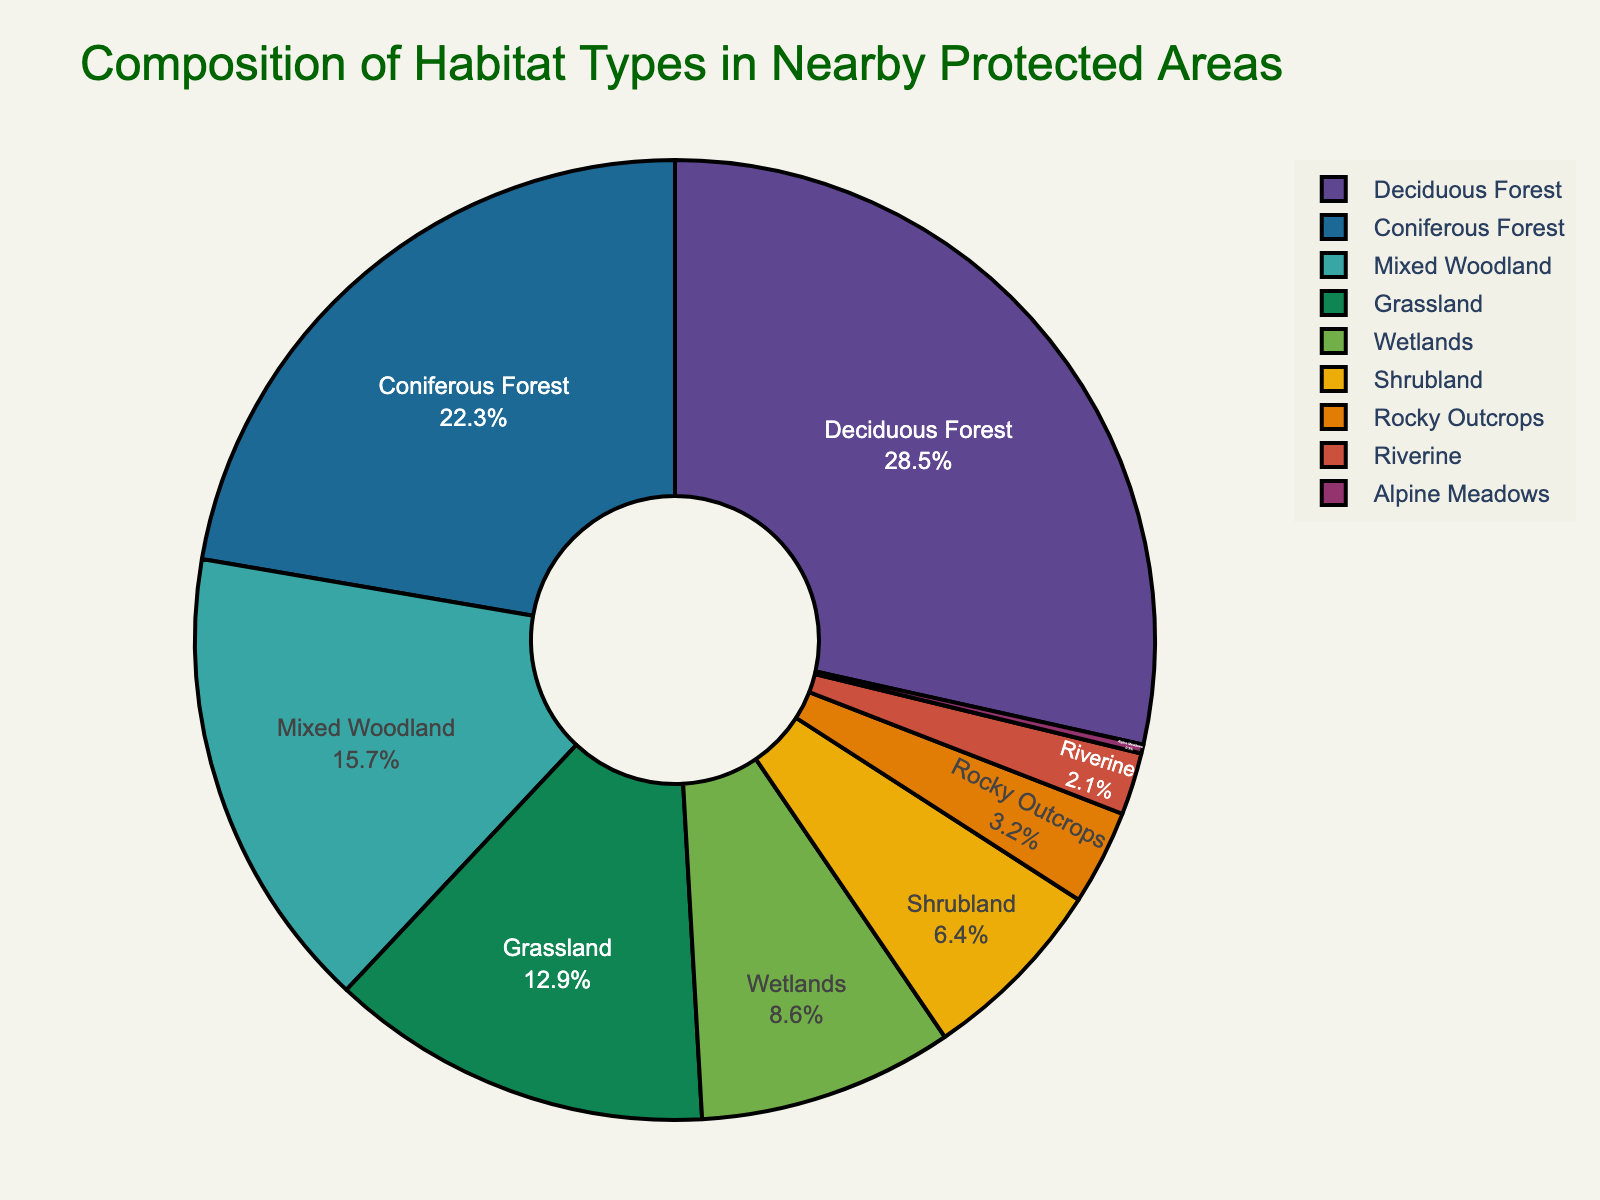What are the top three habitat types by percentage? To find the top three habitat types by percentage, we refer to the slice sizes in the pie chart. The top three are: Deciduous Forest (28.5%), Coniferous Forest (22.3%), and Mixed Woodland (15.7%).
Answer: Deciduous Forest, Coniferous Forest, Mixed Woodland Which habitat type occupies the smallest percentage in the protected areas? Look for the smallest slice in the pie chart. The Alpine Meadows slice is the smallest, occupying 0.3% of the area.
Answer: Alpine Meadows What is the combined percentage of wetlands, shrubland, and rocky outcrops? Add the percentages of Wetlands (8.6%), Shrubland (6.4%), and Rocky Outcrops (3.2%). 8.6 + 6.4 + 3.2 = 18.2%.
Answer: 18.2% How does the percentage of coniferous forest compare to grassland? Refer to the chart slices. Coniferous Forest is 22.3%, and Grassland is 12.9%. Coniferous Forest is more than Grassland by 22.3 - 12.9 = 9.4%.
Answer: Coniferous Forest is 9.4% more than Grassland Which two habitat types combined have a percentage closest to 30%? Examine the chart and add various pairs to find the closest sum to 30%. Deciduous Forest (28.5%) and Alpine Meadows (0.3%) sum to 28.8%, which is the closest to 30%.
Answer: Deciduous Forest and Alpine Meadows What is the difference in percentage between the habitat type with the second largest area and the habitat type with the fifth largest area? The second largest is Coniferous Forest (22.3%), and the fifth largest is Wetlands (8.6%). The difference is 22.3 - 8.6 = 13.7%.
Answer: 13.7% Which habitats together make up more than 50% of the protected areas? Add the largest percentages until the sum exceeds 50%. Deciduous Forest (28.5%) + Coniferous Forest (22.3%) = 50.8%, which just exceeds 50%.
Answer: Deciduous Forest, Coniferous Forest In terms of habitat area percentage, which habitats are least represented (below 5%)? Identify the slices with percentages below 5%. They are Rocky Outcrops (3.2%), Riverine (2.1%), and Alpine Meadows (0.3%).
Answer: Rocky Outcrops, Riverine, Alpine Meadows What color is assigned to the Grassland habitat? Examine the pie chart and locate the color of the slice for Grassland, typically labeled directly.
Answer: [Answer based on visual inspection] 